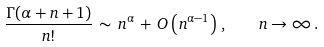Convert formula to latex. <formula><loc_0><loc_0><loc_500><loc_500>\frac { \Gamma ( \alpha + n + 1 ) } { n ! } \, \sim \, n ^ { \alpha } \, + \, O \left ( n ^ { \alpha - 1 } \right ) \, , \quad n \to \infty \, .</formula> 